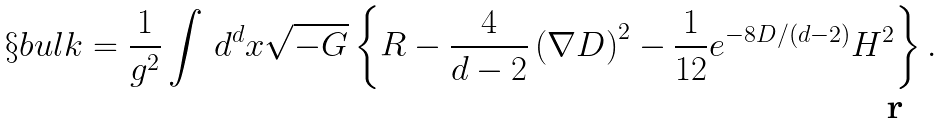Convert formula to latex. <formula><loc_0><loc_0><loc_500><loc_500>\S { b u l k } = \frac { 1 } { g ^ { 2 } } \int \, d ^ { d } x \sqrt { - G } \left \{ R - \frac { 4 } { d - 2 } \left ( \nabla D \right ) ^ { 2 } - \frac { 1 } { 1 2 } e ^ { - 8 D / ( d - 2 ) } H ^ { 2 } \right \} .</formula> 